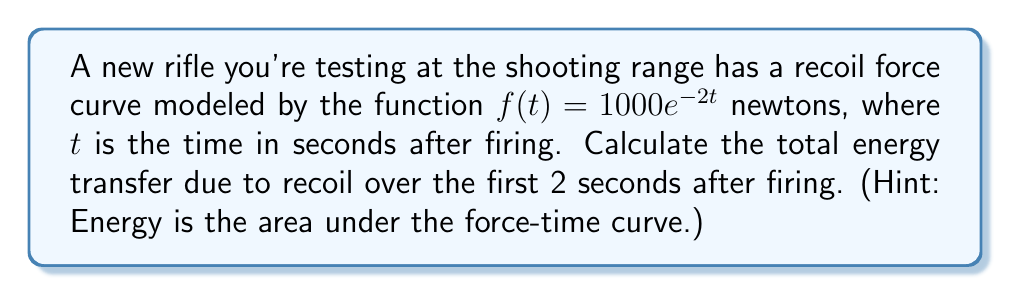Can you answer this question? To find the total energy transfer, we need to calculate the area under the recoil force curve from $t=0$ to $t=2$ seconds. This can be done using integration:

1) Set up the definite integral:
   $$E = \int_0^2 f(t) dt = \int_0^2 1000e^{-2t} dt$$

2) Use the substitution method with $u = -2t$:
   $du = -2dt$, so $dt = -\frac{1}{2}du$

3) Change the limits of integration:
   When $t = 0$, $u = 0$
   When $t = 2$, $u = -4$

4) Rewrite the integral:
   $$E = -500 \int_0^{-4} e^u du$$

5) Integrate:
   $$E = -500 [e^u]_0^{-4}$$

6) Evaluate the integral:
   $$E = -500 (e^{-4} - e^0) = -500 (e^{-4} - 1)$$

7) Calculate the final result:
   $$E = 500 (1 - e^{-4}) \approx 495.4 \text{ joules}$$
Answer: $500(1-e^{-4}) \approx 495.4 \text{ J}$ 